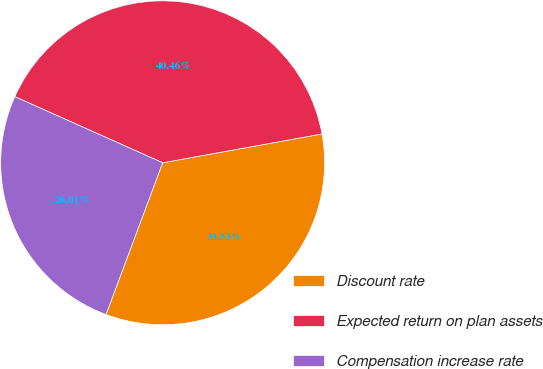Convert chart to OTSL. <chart><loc_0><loc_0><loc_500><loc_500><pie_chart><fcel>Discount rate<fcel>Expected return on plan assets<fcel>Compensation increase rate<nl><fcel>33.53%<fcel>40.46%<fcel>26.01%<nl></chart> 